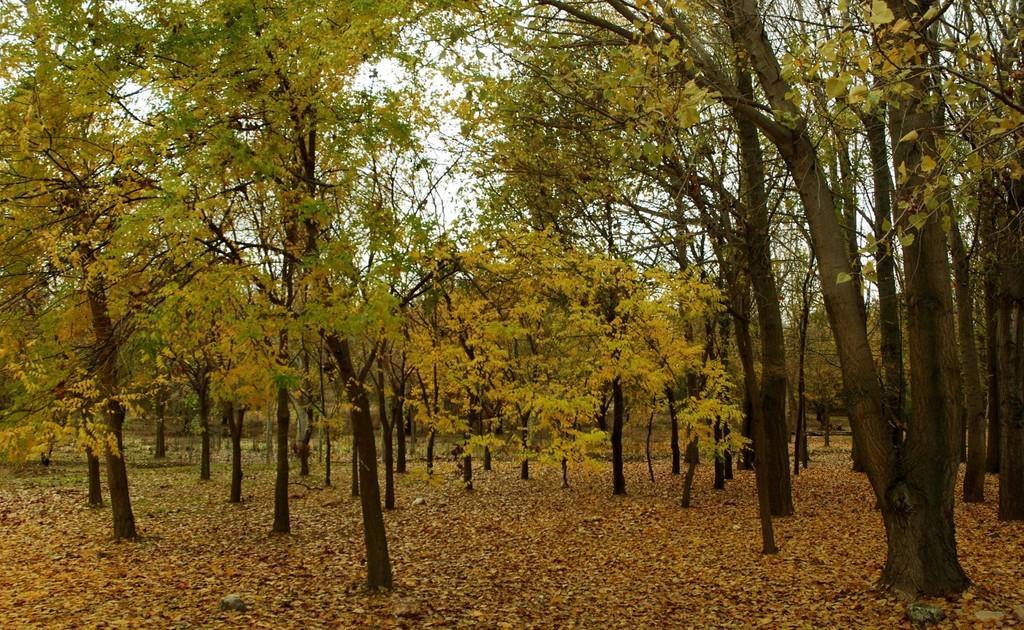Can you describe this image briefly? In this image we can see there are trees and dry leaves on the surface. 